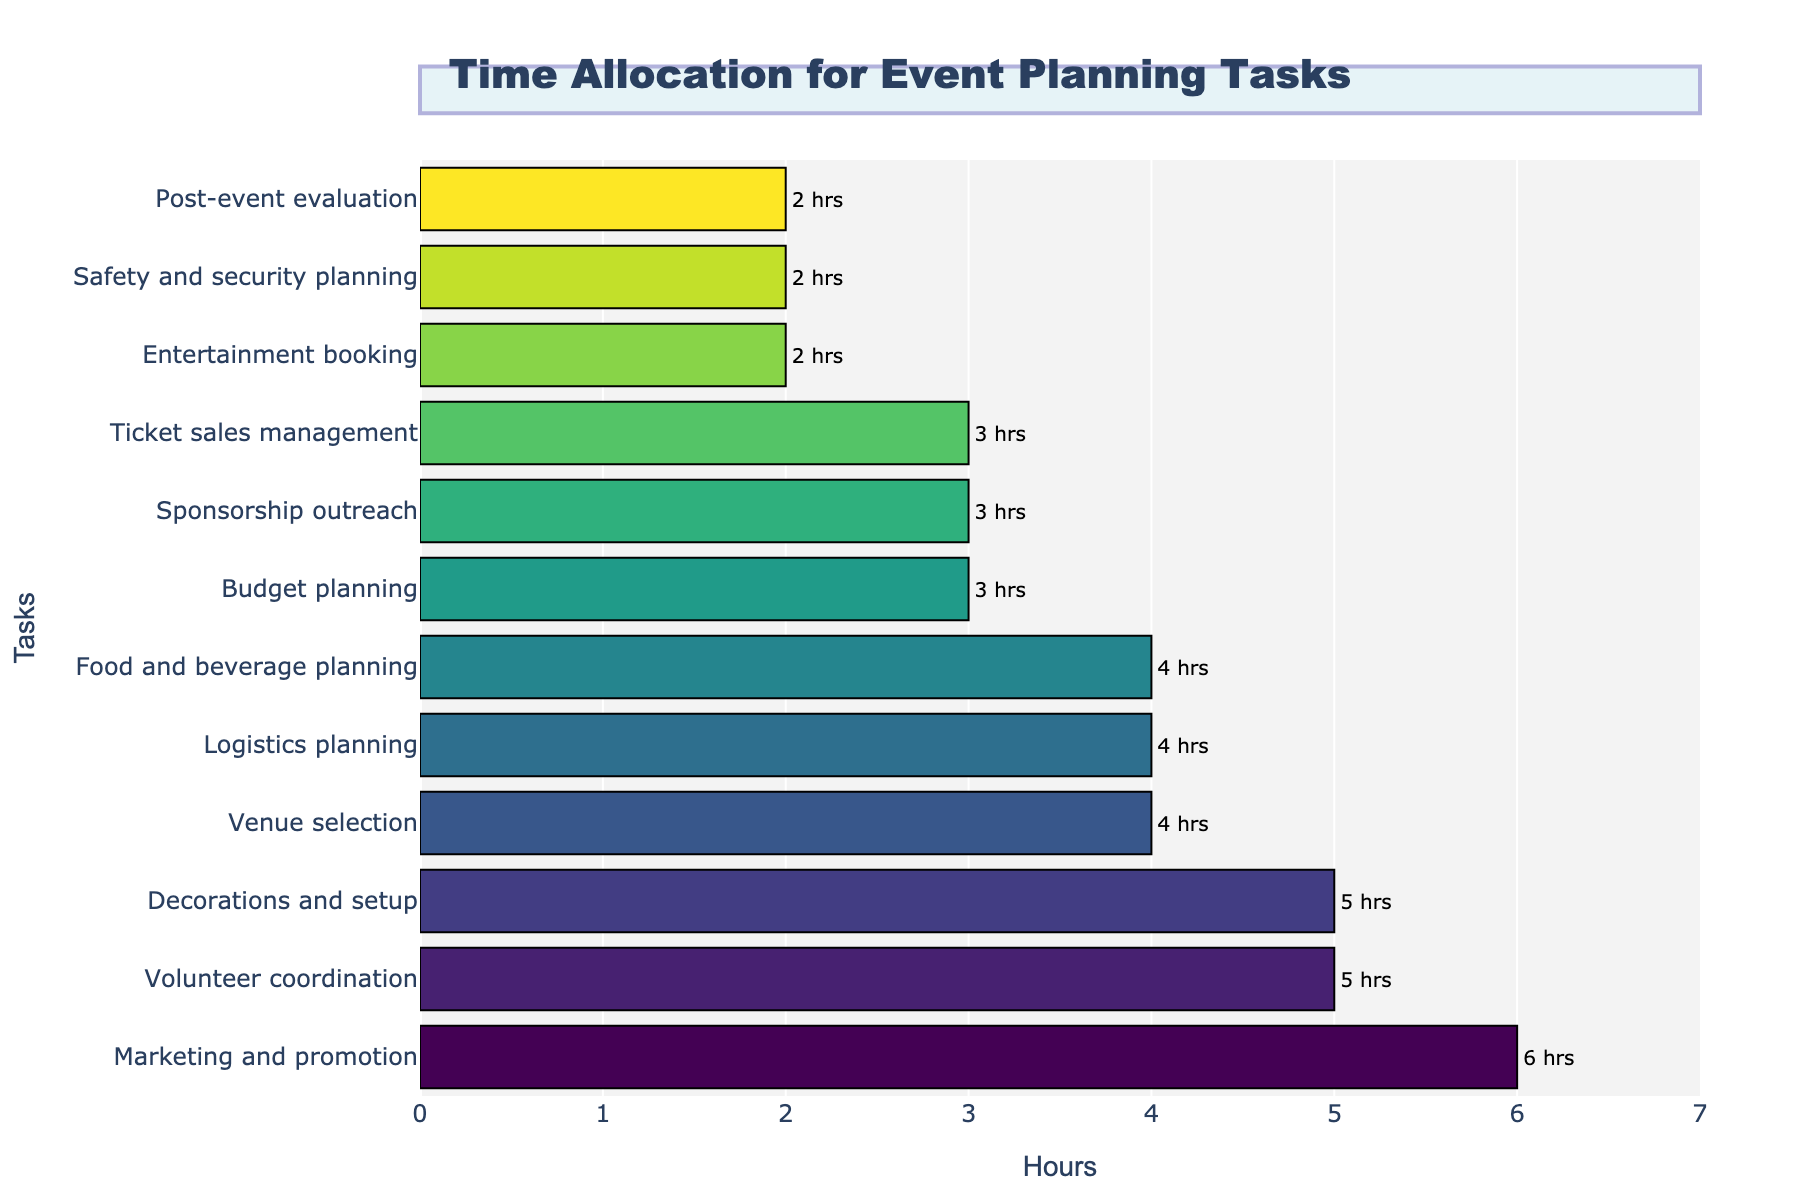What task has the highest time allocation? To determine the task with the highest time allocation, we look at the bar with the greatest length. This represents the task with the most hours allocated.
Answer: Marketing and promotion What is the total time spent on tasks that involve booking or planning (Entertainment booking, Food and beverage planning)? Sum the hours allocated to these tasks: Entertainment booking is 2 hours, and Food and beverage planning is 4 hours. Thus, total time: 2 + 4.
Answer: 6 hours Which task takes the least amount of time? To find the task with the least amount of time, identify the shortest bar in the chart. This represents the task with the smallest hours allocated.
Answer: Entertainment booking, Safety and security planning, Post-event evaluation How much more time is spent on Marketing and promotion compared to Budget planning? Identify the hours spent on each task and subtract the lesser from the greater. Marketing and promotion is 6 hours, and Budget planning is 3 hours. So, 6 - 3.
Answer: 3 hours Are there any tasks that are allocated exactly 4 hours? If so, which ones? Check the bars that have a length corresponding to 4 hours.
Answer: Venue selection, Logistics planning, Food and beverage planning Which task has an equal number of hours as Sponsorship outreach? Look for bars with the same length as Sponsorship outreach, which is 3 hours.
Answer: Budget planning, Ticket sales management What is the combined time spent on Venue selection and Volunteer coordination? Sum the hours allocated to these two tasks: Venue selection is 4 hours, and Volunteer coordination is 5 hours. Thus, 4 + 5.
Answer: 9 hours Which tasks take exactly 2 hours? Identify all bars that represent 2 hours.
Answer: Entertainment booking, Safety and security planning, Post-event evaluation Of the tasks that take 4 hours, which one is related to planning logistics? Identify tasks taking 4 hours and check for any related to planning logistics.
Answer: Logistics planning How many tasks take more than 3 hours? Count the number of bars that represent more than 3 hours.
Answer: 5 tasks 